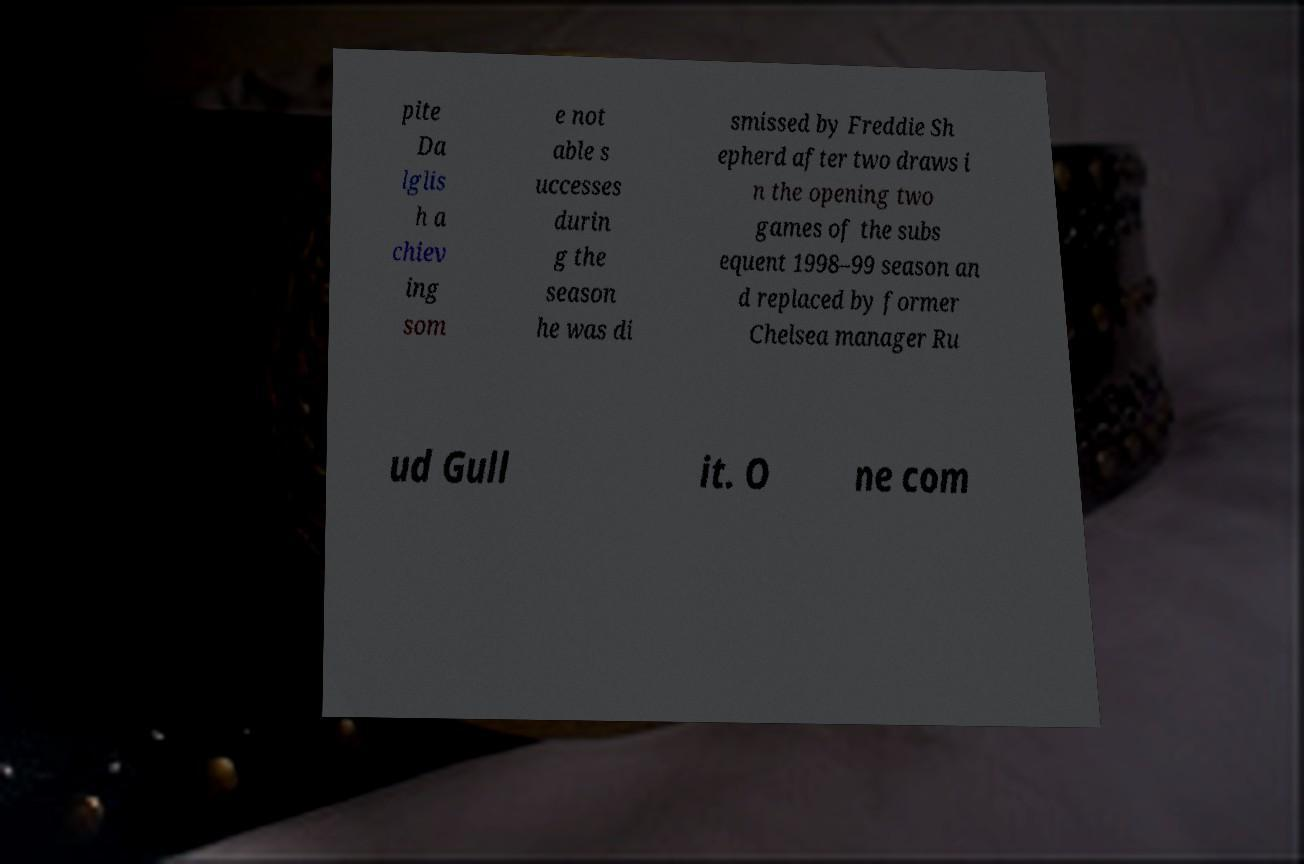Please identify and transcribe the text found in this image. pite Da lglis h a chiev ing som e not able s uccesses durin g the season he was di smissed by Freddie Sh epherd after two draws i n the opening two games of the subs equent 1998–99 season an d replaced by former Chelsea manager Ru ud Gull it. O ne com 